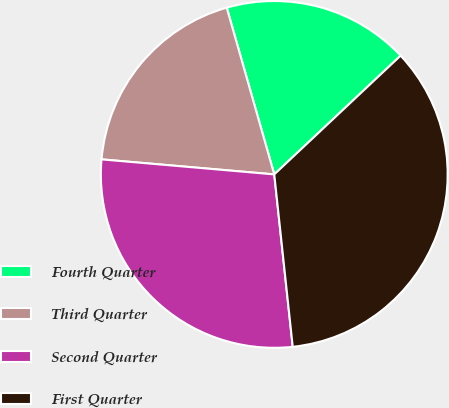Convert chart. <chart><loc_0><loc_0><loc_500><loc_500><pie_chart><fcel>Fourth Quarter<fcel>Third Quarter<fcel>Second Quarter<fcel>First Quarter<nl><fcel>17.41%<fcel>19.2%<fcel>28.08%<fcel>35.31%<nl></chart> 